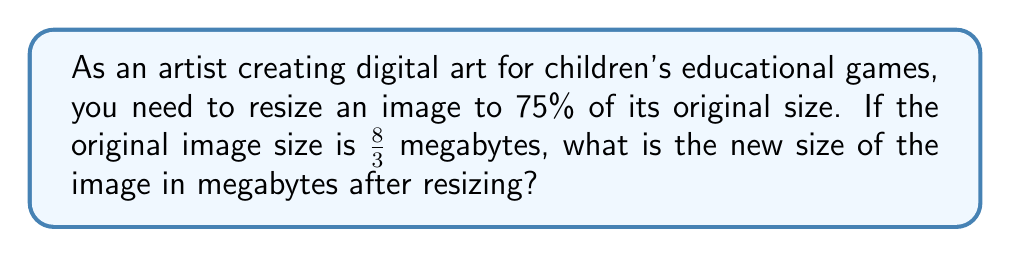Show me your answer to this math problem. To solve this problem, we need to follow these steps:

1. Convert the fraction $\frac{8}{3}$ to a decimal:
   $\frac{8}{3} = 8 \div 3 = 2.6666...$

2. Calculate 75% of the original size:
   75% = $\frac{75}{100} = 0.75$

3. Multiply the original size by 0.75:
   $2.6666... \times 0.75 = 2$

Therefore, the new size of the image after resizing to 75% of its original size is 2 megabytes.

This problem demonstrates how converting fractions to decimals is useful in digital image manipulation, making it relevant to both the artistic and technological aspects of engaging children in learning.
Answer: 2 megabytes 